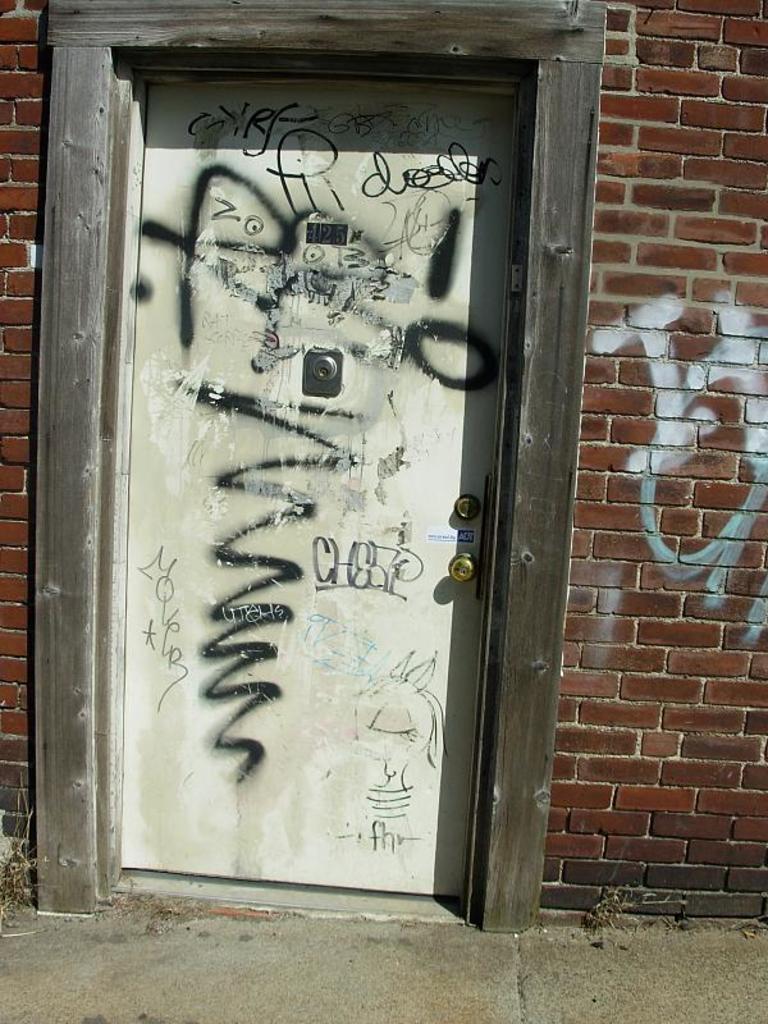In one or two sentences, can you explain what this image depicts? This is the picture of a building. There is a text on the door and on the wall. At the bottom there is a road. 